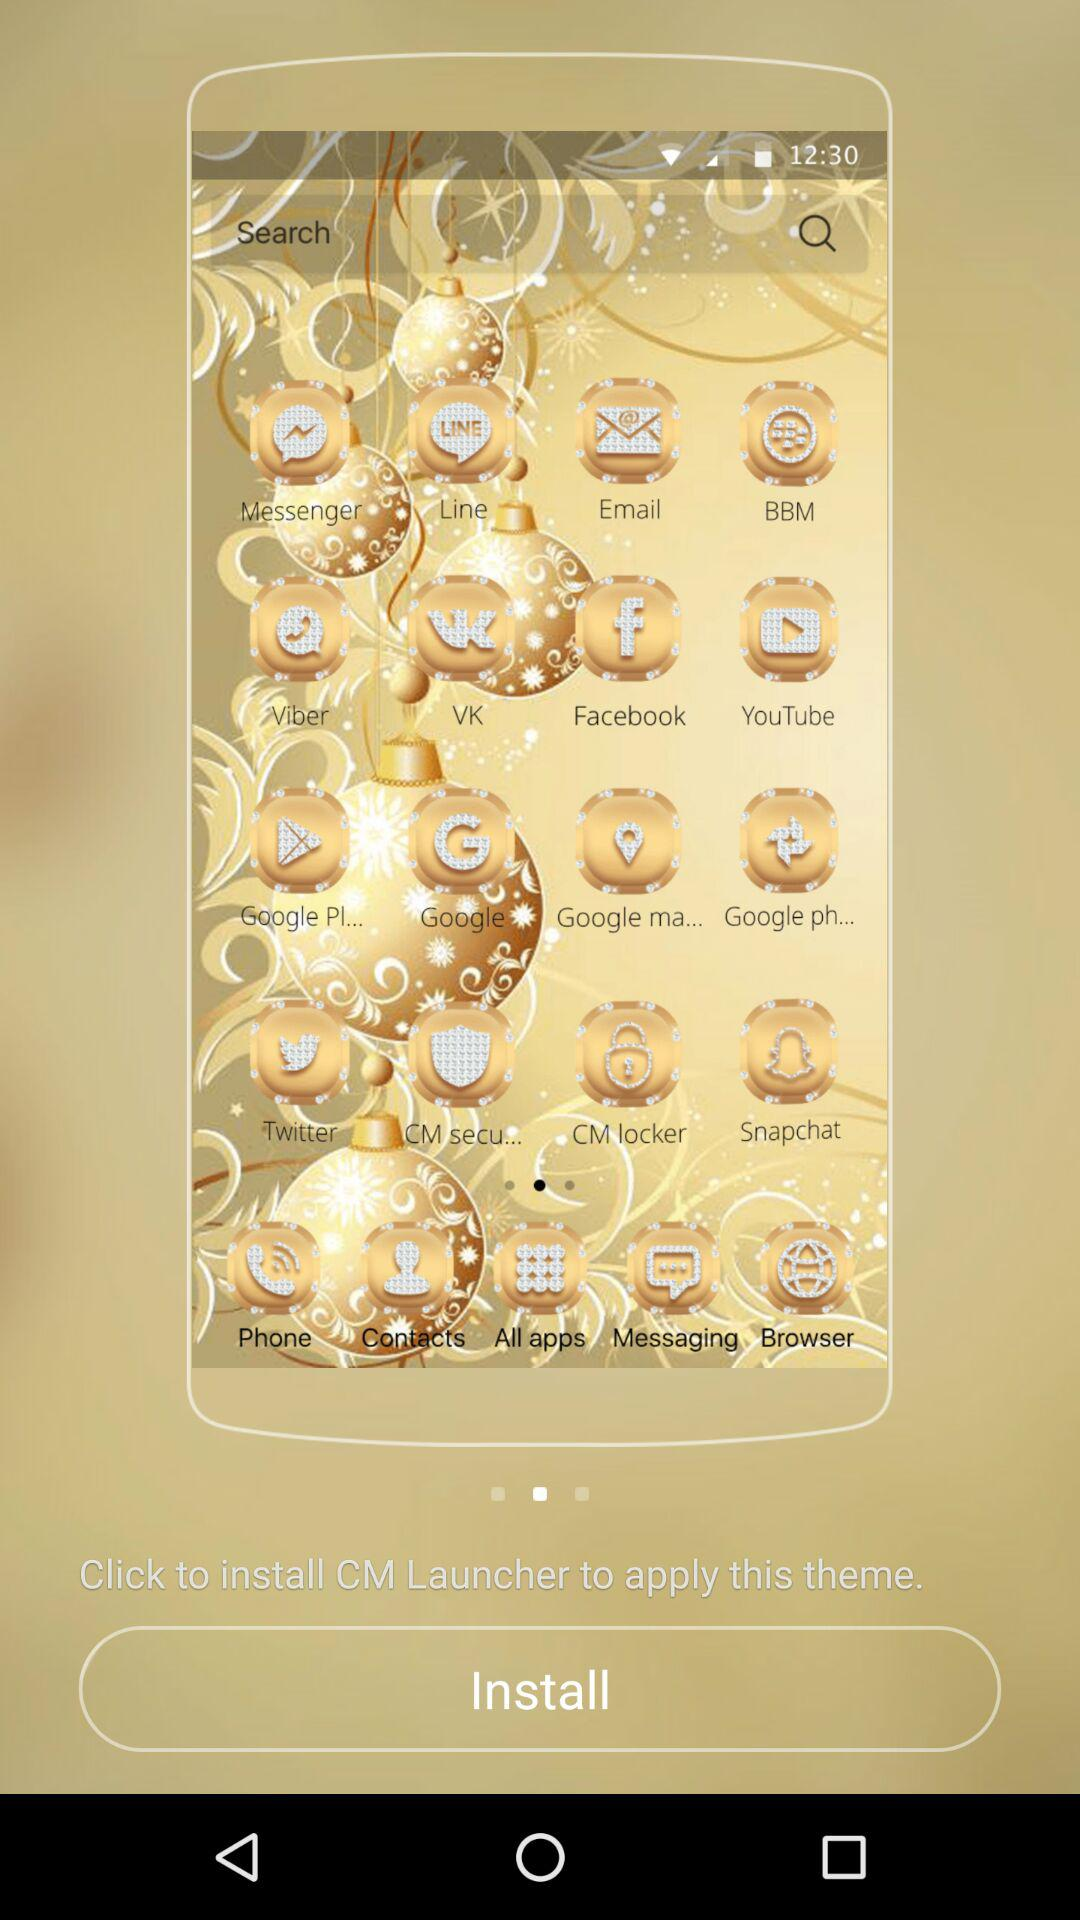What app is to be installed? The app that is to be installed is "CM Launcher". 